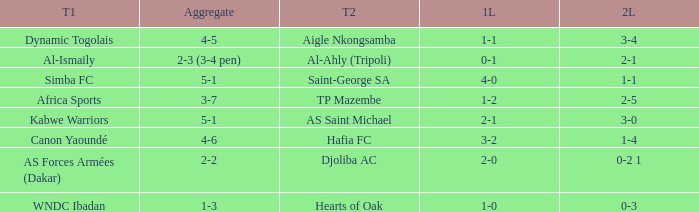What was the 2nd leg result in the match that scored a 2-0 in the 1st leg? 0-2 1. Write the full table. {'header': ['T1', 'Aggregate', 'T2', '1L', '2L'], 'rows': [['Dynamic Togolais', '4-5', 'Aigle Nkongsamba', '1-1', '3-4'], ['Al-Ismaily', '2-3 (3-4 pen)', 'Al-Ahly (Tripoli)', '0-1', '2-1'], ['Simba FC', '5-1', 'Saint-George SA', '4-0', '1-1'], ['Africa Sports', '3-7', 'TP Mazembe', '1-2', '2-5'], ['Kabwe Warriors', '5-1', 'AS Saint Michael', '2-1', '3-0'], ['Canon Yaoundé', '4-6', 'Hafia FC', '3-2', '1-4'], ['AS Forces Armées (Dakar)', '2-2', 'Djoliba AC', '2-0', '0-2 1'], ['WNDC Ibadan', '1-3', 'Hearts of Oak', '1-0', '0-3']]} 